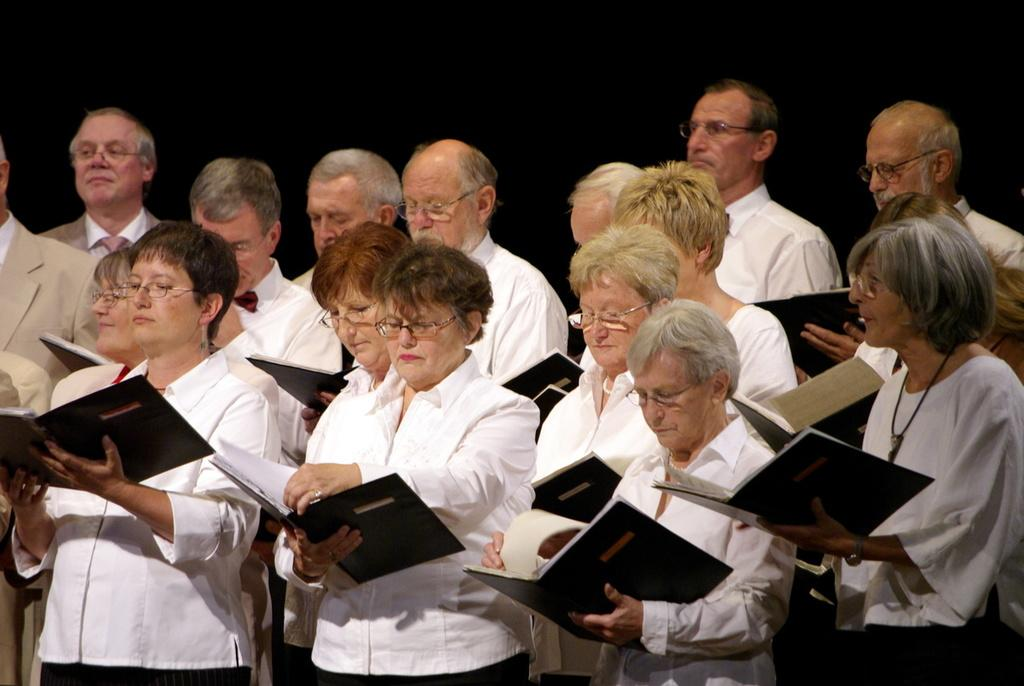Who or what is present in the image? There are people in the image. What are the people doing in the image? The people are standing. What objects are the people holding in the image? The people are holding books in their hands. What type of waste can be seen in the image? There is no waste present in the image; it features people standing and holding books. What kind of van is visible in the image? There is no van present in the image. 